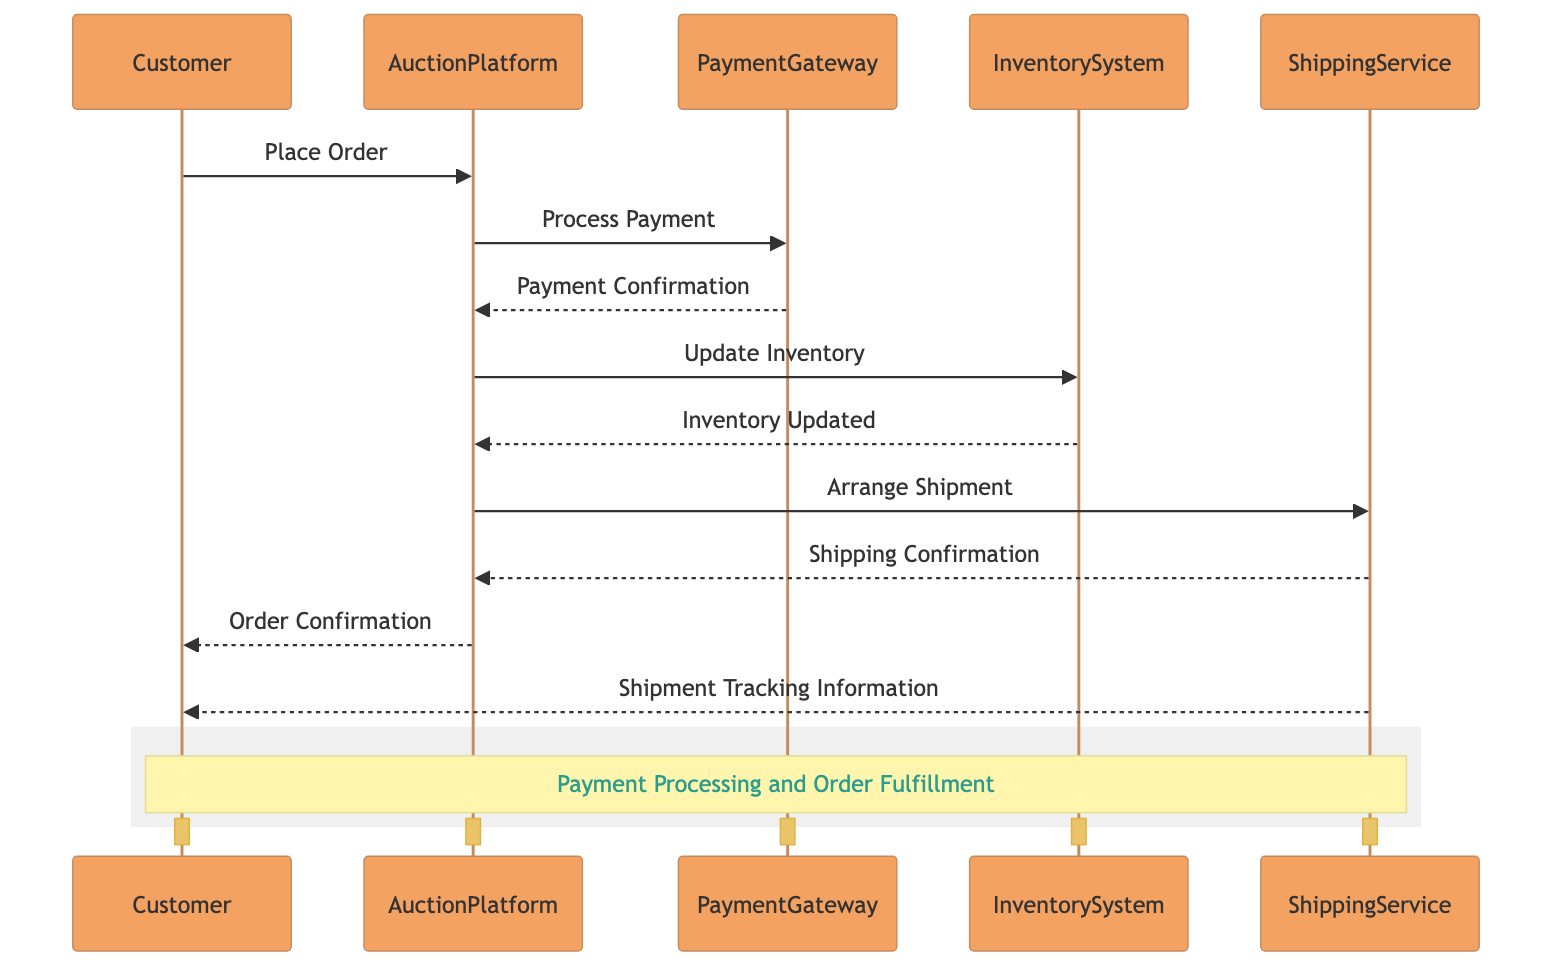What are the actors involved in the payment processing and order fulfillment? The diagram includes five actors: Customer, AuctionPlatform, PaymentGateway, InventorySystem, and ShippingService. Each actor has a distinct role in the process.
Answer: Customer, AuctionPlatform, PaymentGateway, InventorySystem, ShippingService Which actor sends the initial order placement? The Customer initiates the process by sending a "Place Order" message to the AuctionPlatform, marking the beginning of the payment processing and order fulfillment sequence.
Answer: Customer How many steps are involved in the payment and order fulfillment process? There are nine steps in total, as indicated by the messages exchanged between actors in the sequence diagram. Each message represents a distinct action within the process.
Answer: Nine Who confirms the payment to the AuctionPlatform? The PaymentGateway sends a "Payment Confirmation" message back to the AuctionPlatform after processing the payment, indicating that the transaction is successful.
Answer: PaymentGateway What message is sent after the inventory is updated? After the InventorySystem updates the inventory, it sends an "Inventory Updated" message back to the AuctionPlatform, ensuring the platform knows about the inventory status.
Answer: Inventory Updated Which actor is responsible for arranging the shipment? The AuctionPlatform is responsible for arranging the shipment by sending an "Arrange Shipment" message to the ShippingService, indicating that the order is ready to be shipped.
Answer: AuctionPlatform What information does the ShippingService provide to the Customer? The ShippingService sends "Shipment Tracking Information" to the Customer, which helps the customer track their order once shipped, completing the fulfillment process.
Answer: Shipment Tracking Information How many control and entity lifelines are present in the diagram? There are one control lifeline (PaymentGateway) and two entity lifelines (InventorySystem and ShippingService) present in the sequence diagram, representing their roles in the process.
Answer: One control and two entity What is the last message sent in the sequence? The last message sent in the sequence is "Shipment Tracking Information," which is sent from the ShippingService to the Customer, finalizing the order fulfillment.
Answer: Shipment Tracking Information 